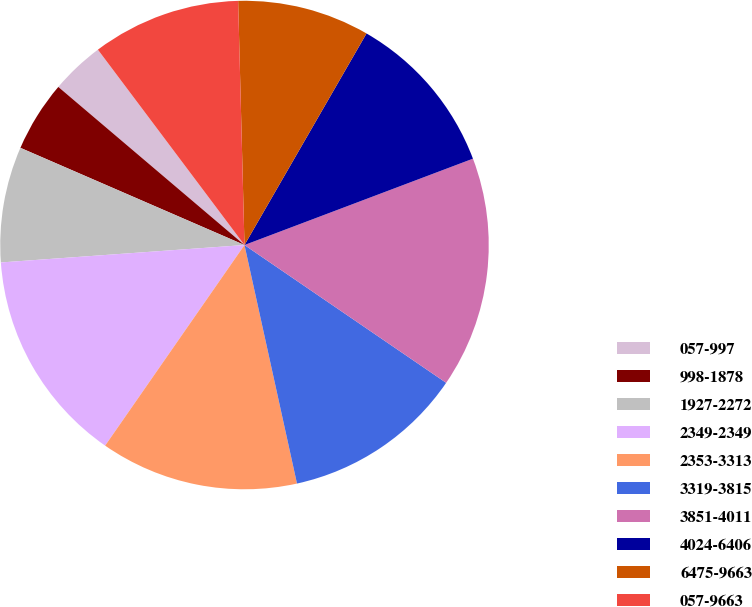<chart> <loc_0><loc_0><loc_500><loc_500><pie_chart><fcel>057-997<fcel>998-1878<fcel>1927-2272<fcel>2349-2349<fcel>2353-3313<fcel>3319-3815<fcel>3851-4011<fcel>4024-6406<fcel>6475-9663<fcel>057-9663<nl><fcel>3.55%<fcel>4.69%<fcel>7.65%<fcel>14.2%<fcel>13.11%<fcel>12.01%<fcel>15.29%<fcel>10.92%<fcel>8.74%<fcel>9.83%<nl></chart> 